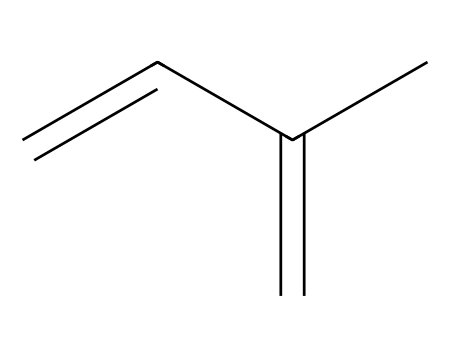What is the name of this chemical? The SMILES representation indicates a structure with a sequence of carbon and double bonds that corresponds to isoprene, which is known as a key monomer in natural rubber production.
Answer: isoprene How many carbon atoms are in isoprene? The SMILES notation C=CC(=C)C shows 5 carbon atoms (C), making a total of five in the entire chain.
Answer: five How many double bonds are present in isoprene? The structure reveals two double bond locations ('='), which indicates the presence of two carbon-carbon double bonds in isoprene.
Answer: two What type of polymer can isoprene form? Isoprene is known to polymerize to form natural rubber, a well-known elastomer, which is a type of polymer that can undergo significant elastic deformation.
Answer: rubber What functional groups are present in isoprene? The structure contains no specific functional groups like hydroxyl or carboxyl; it primarily consists of aliphatic carbons and double bonds, typical of unsaturated hydrocarbons.
Answer: none What is the hybridization of the carbon atoms in isoprene? Carbon atoms involved in double bonds exhibit sp2 hybridization due to the linear arrangement around the double bond, while the carbon atoms involved only in single bonds are sp3 hybridized. Therefore, the hybridization pattern varies in isoprene.
Answer: sp2 and sp3 